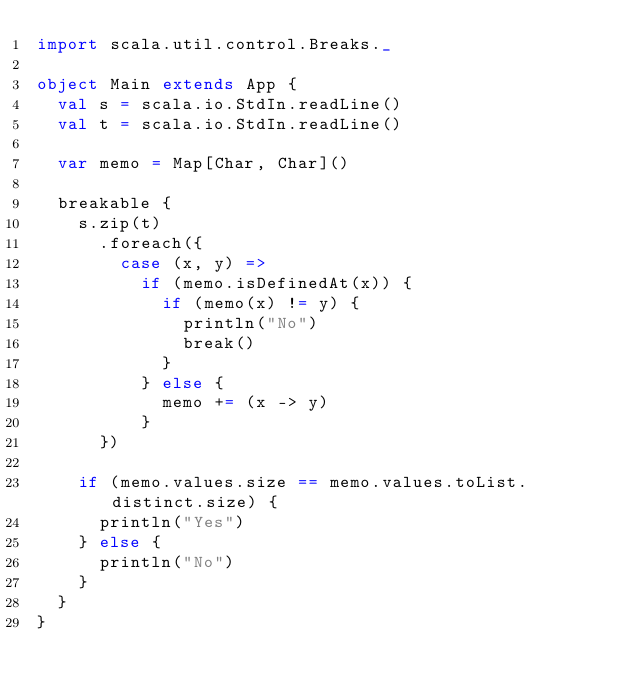Convert code to text. <code><loc_0><loc_0><loc_500><loc_500><_Scala_>import scala.util.control.Breaks._

object Main extends App {
  val s = scala.io.StdIn.readLine()
  val t = scala.io.StdIn.readLine()

  var memo = Map[Char, Char]()

  breakable {
    s.zip(t)
      .foreach({
        case (x, y) =>
          if (memo.isDefinedAt(x)) {
            if (memo(x) != y) {
              println("No")
              break()
            }
          } else {
            memo += (x -> y)
          }
      })

    if (memo.values.size == memo.values.toList.distinct.size) {
      println("Yes")
    } else {
      println("No")
    }
  }
}
</code> 